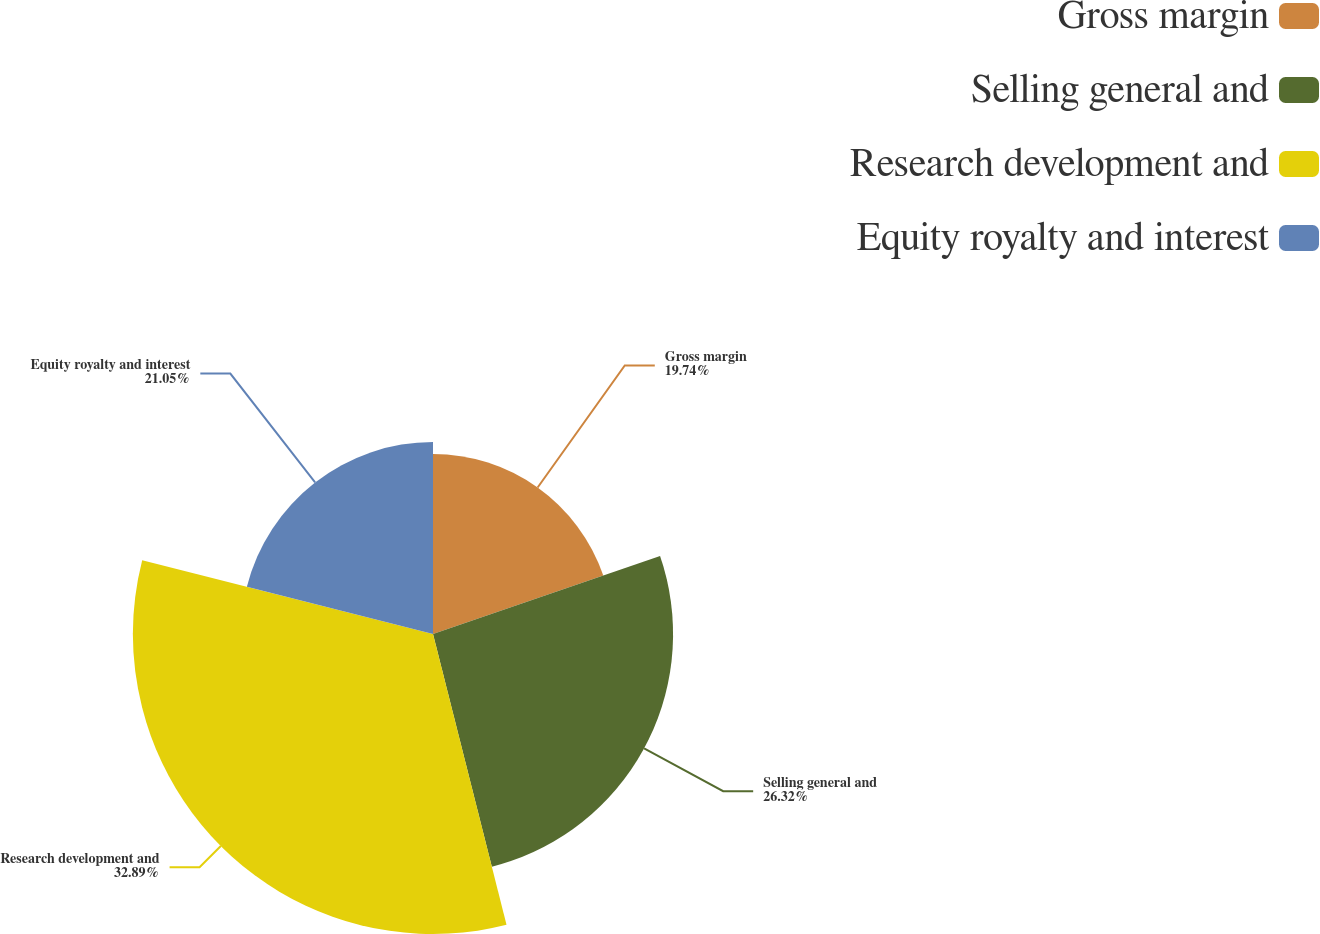Convert chart to OTSL. <chart><loc_0><loc_0><loc_500><loc_500><pie_chart><fcel>Gross margin<fcel>Selling general and<fcel>Research development and<fcel>Equity royalty and interest<nl><fcel>19.74%<fcel>26.32%<fcel>32.89%<fcel>21.05%<nl></chart> 